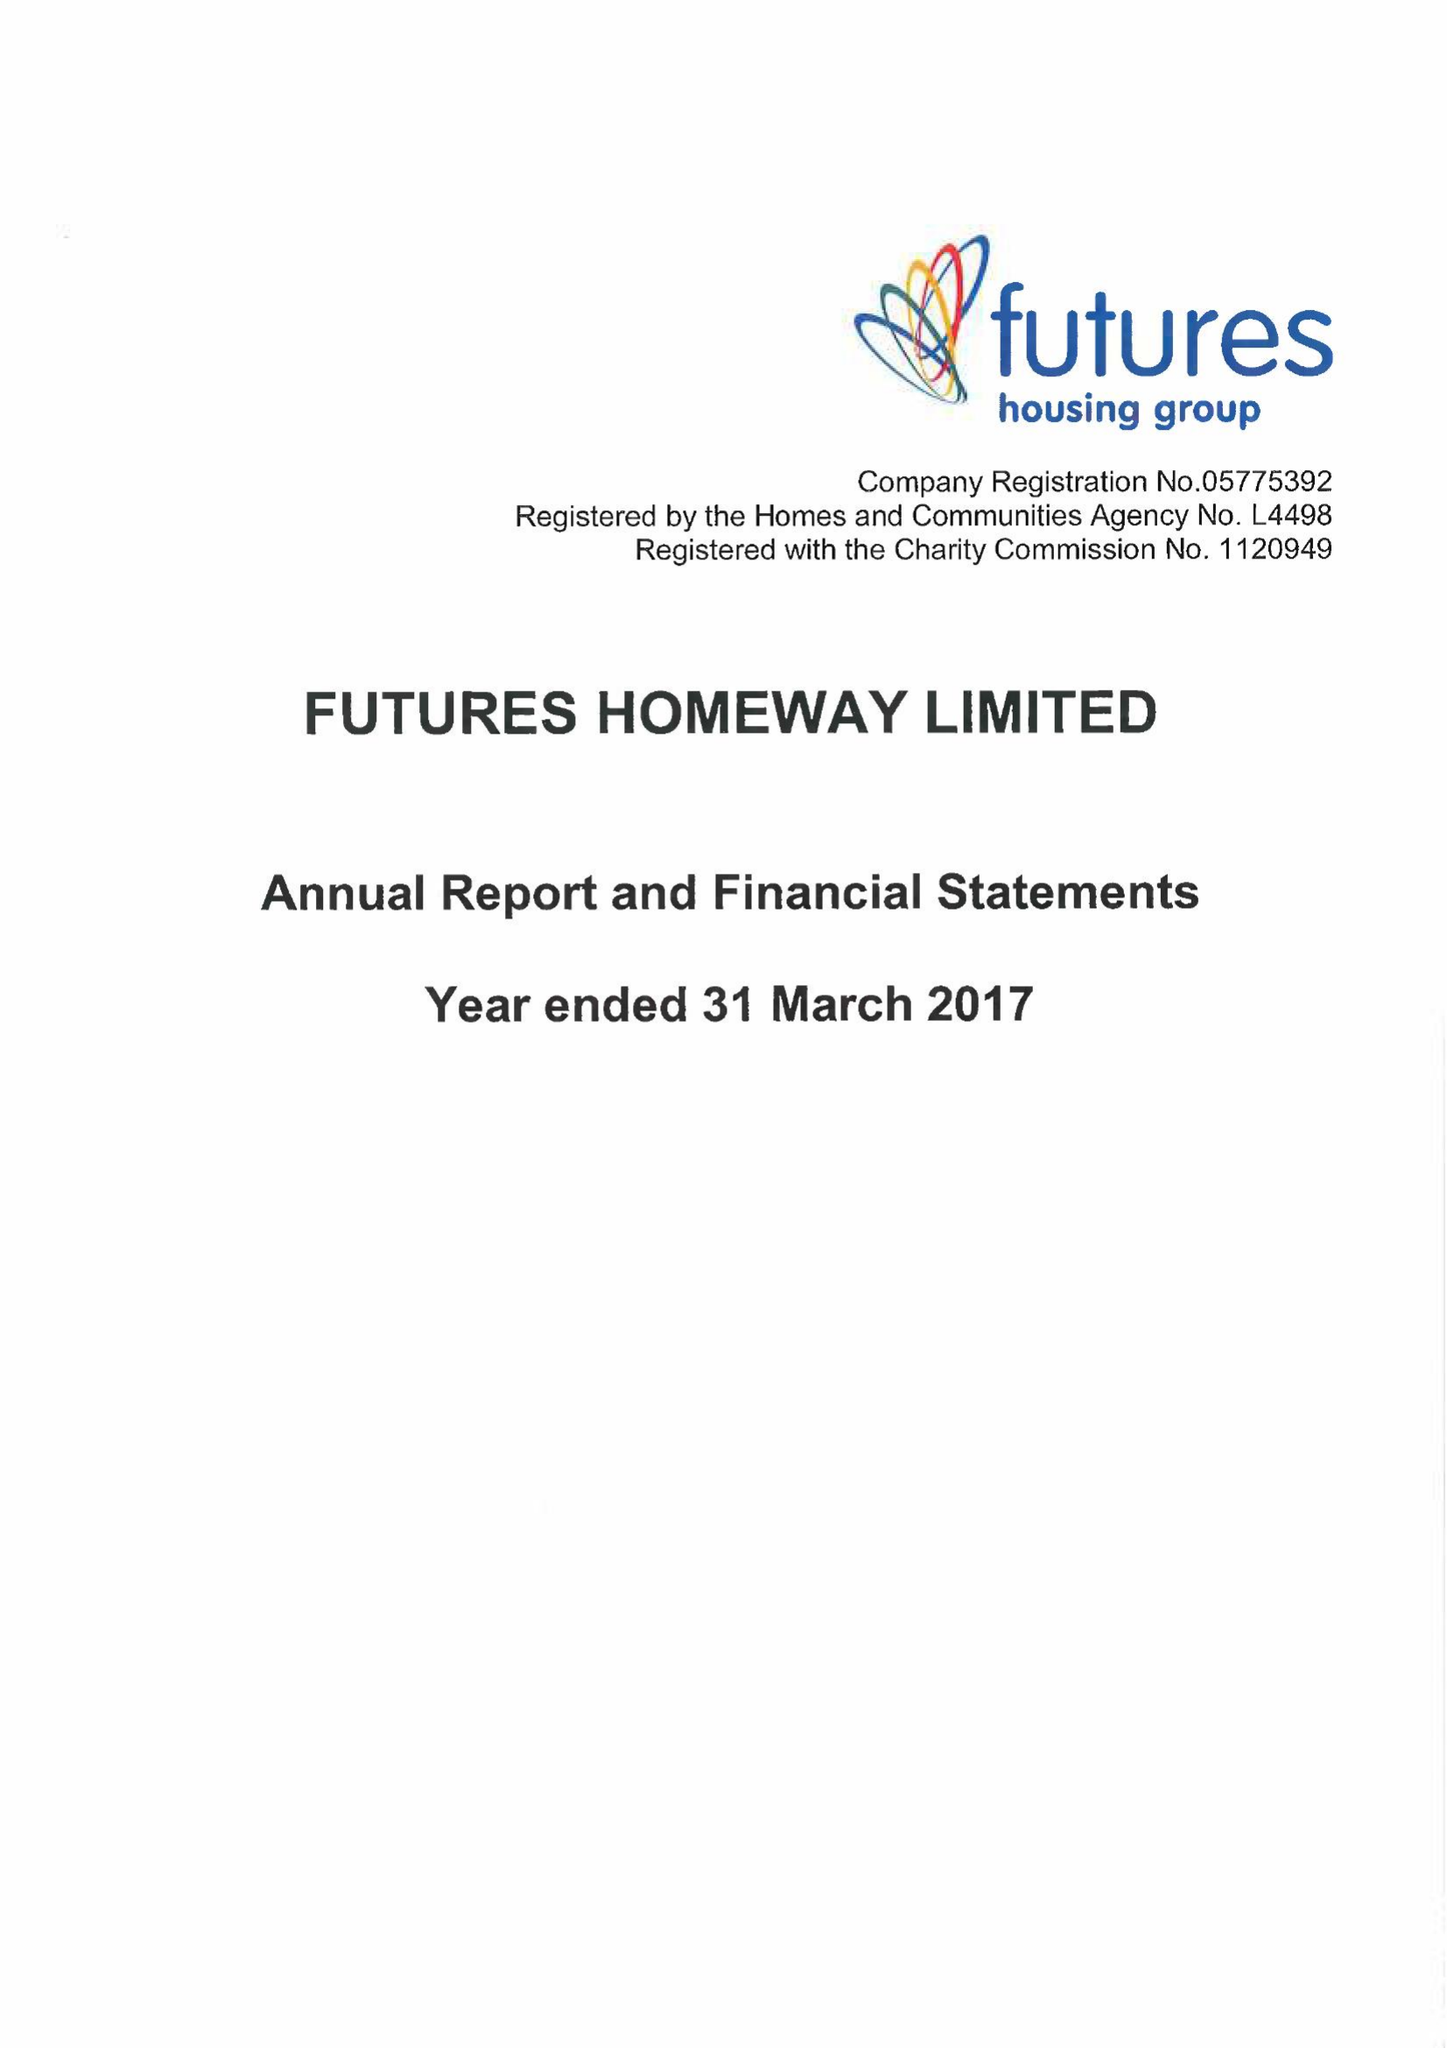What is the value for the spending_annually_in_british_pounds?
Answer the question using a single word or phrase. 12736000.00 